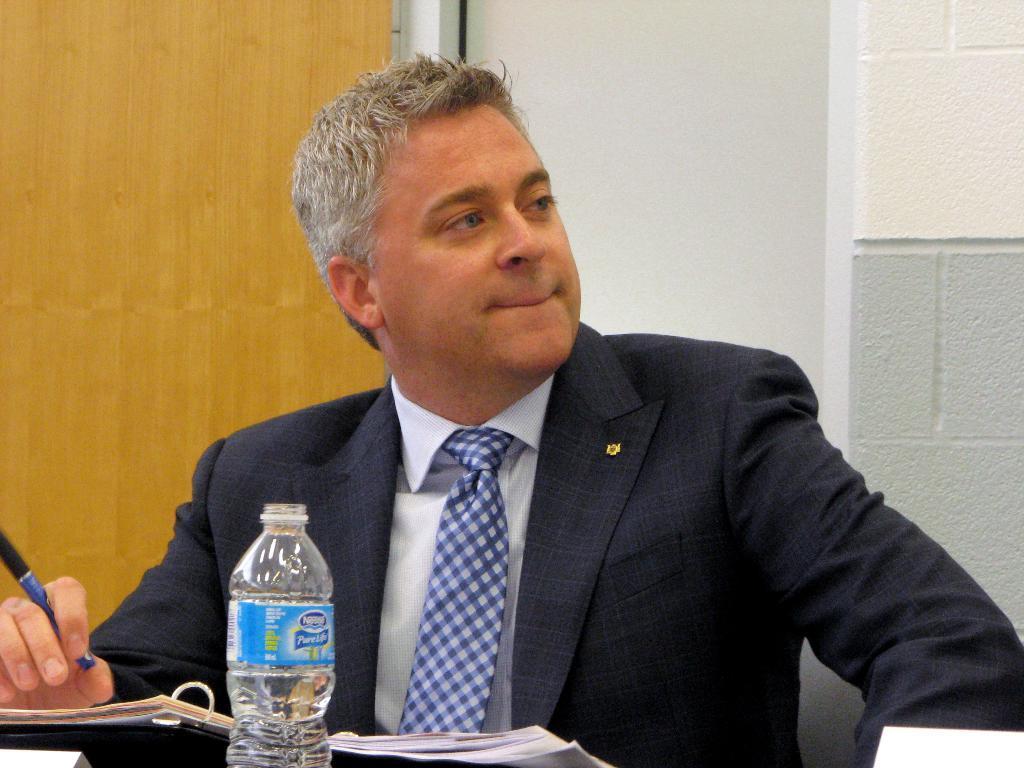In one or two sentences, can you explain what this image depicts? This a picture of a man who has grey hair and wearing a blue suit and tie and has a pen in his hand sitting on the chair in front of the table and on the table we have a bottle and a file with papers. 